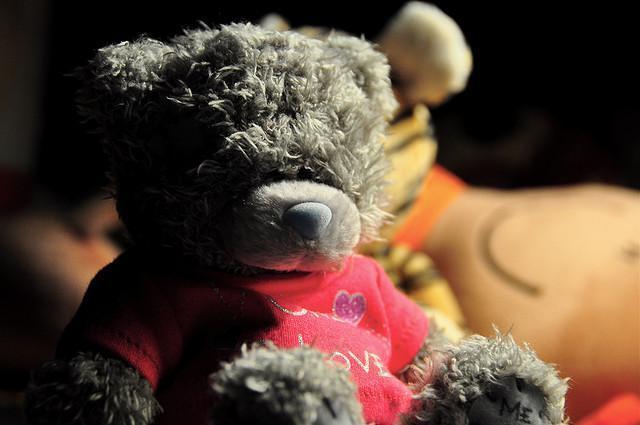How many people have stripped shirts?
Give a very brief answer. 0. 